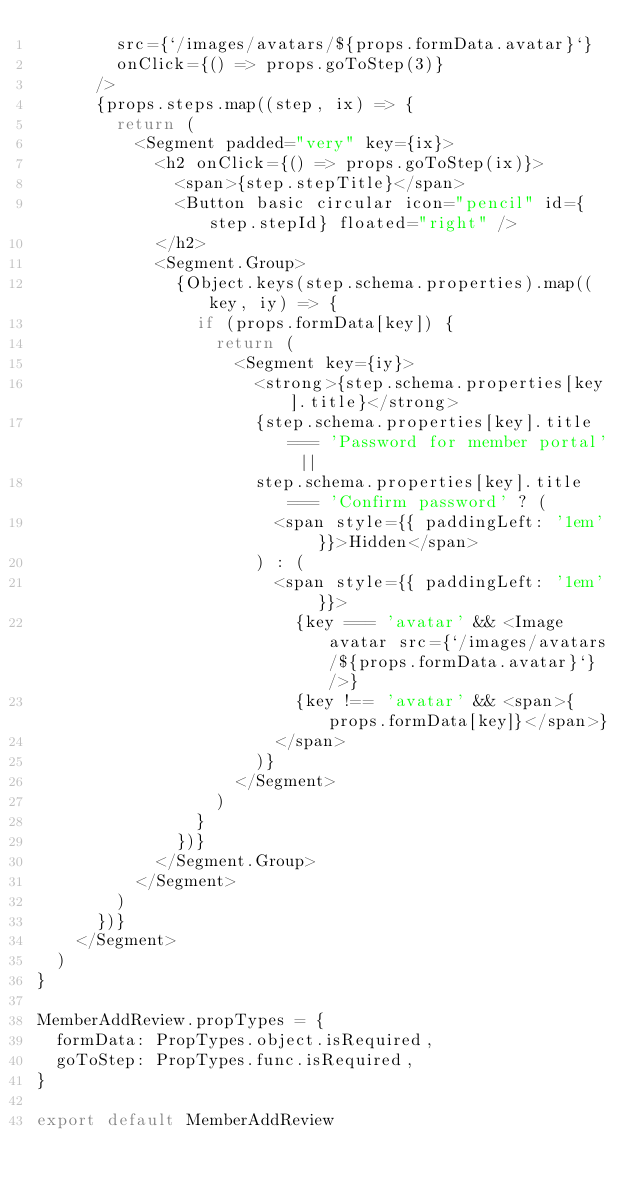<code> <loc_0><loc_0><loc_500><loc_500><_JavaScript_>        src={`/images/avatars/${props.formData.avatar}`}
        onClick={() => props.goToStep(3)}
      />
      {props.steps.map((step, ix) => {
        return (
          <Segment padded="very" key={ix}>
            <h2 onClick={() => props.goToStep(ix)}>
              <span>{step.stepTitle}</span>
              <Button basic circular icon="pencil" id={step.stepId} floated="right" />
            </h2>
            <Segment.Group>
              {Object.keys(step.schema.properties).map((key, iy) => {
                if (props.formData[key]) {
                  return (
                    <Segment key={iy}>
                      <strong>{step.schema.properties[key].title}</strong>
                      {step.schema.properties[key].title === 'Password for member portal' ||
                      step.schema.properties[key].title === 'Confirm password' ? (
                        <span style={{ paddingLeft: '1em' }}>Hidden</span>
                      ) : (
                        <span style={{ paddingLeft: '1em' }}>
                          {key === 'avatar' && <Image avatar src={`/images/avatars/${props.formData.avatar}`} />}
                          {key !== 'avatar' && <span>{props.formData[key]}</span>}
                        </span>
                      )}
                    </Segment>
                  )
                }
              })}
            </Segment.Group>
          </Segment>
        )
      })}
    </Segment>
  )
}

MemberAddReview.propTypes = {
  formData: PropTypes.object.isRequired,
  goToStep: PropTypes.func.isRequired,
}

export default MemberAddReview
</code> 